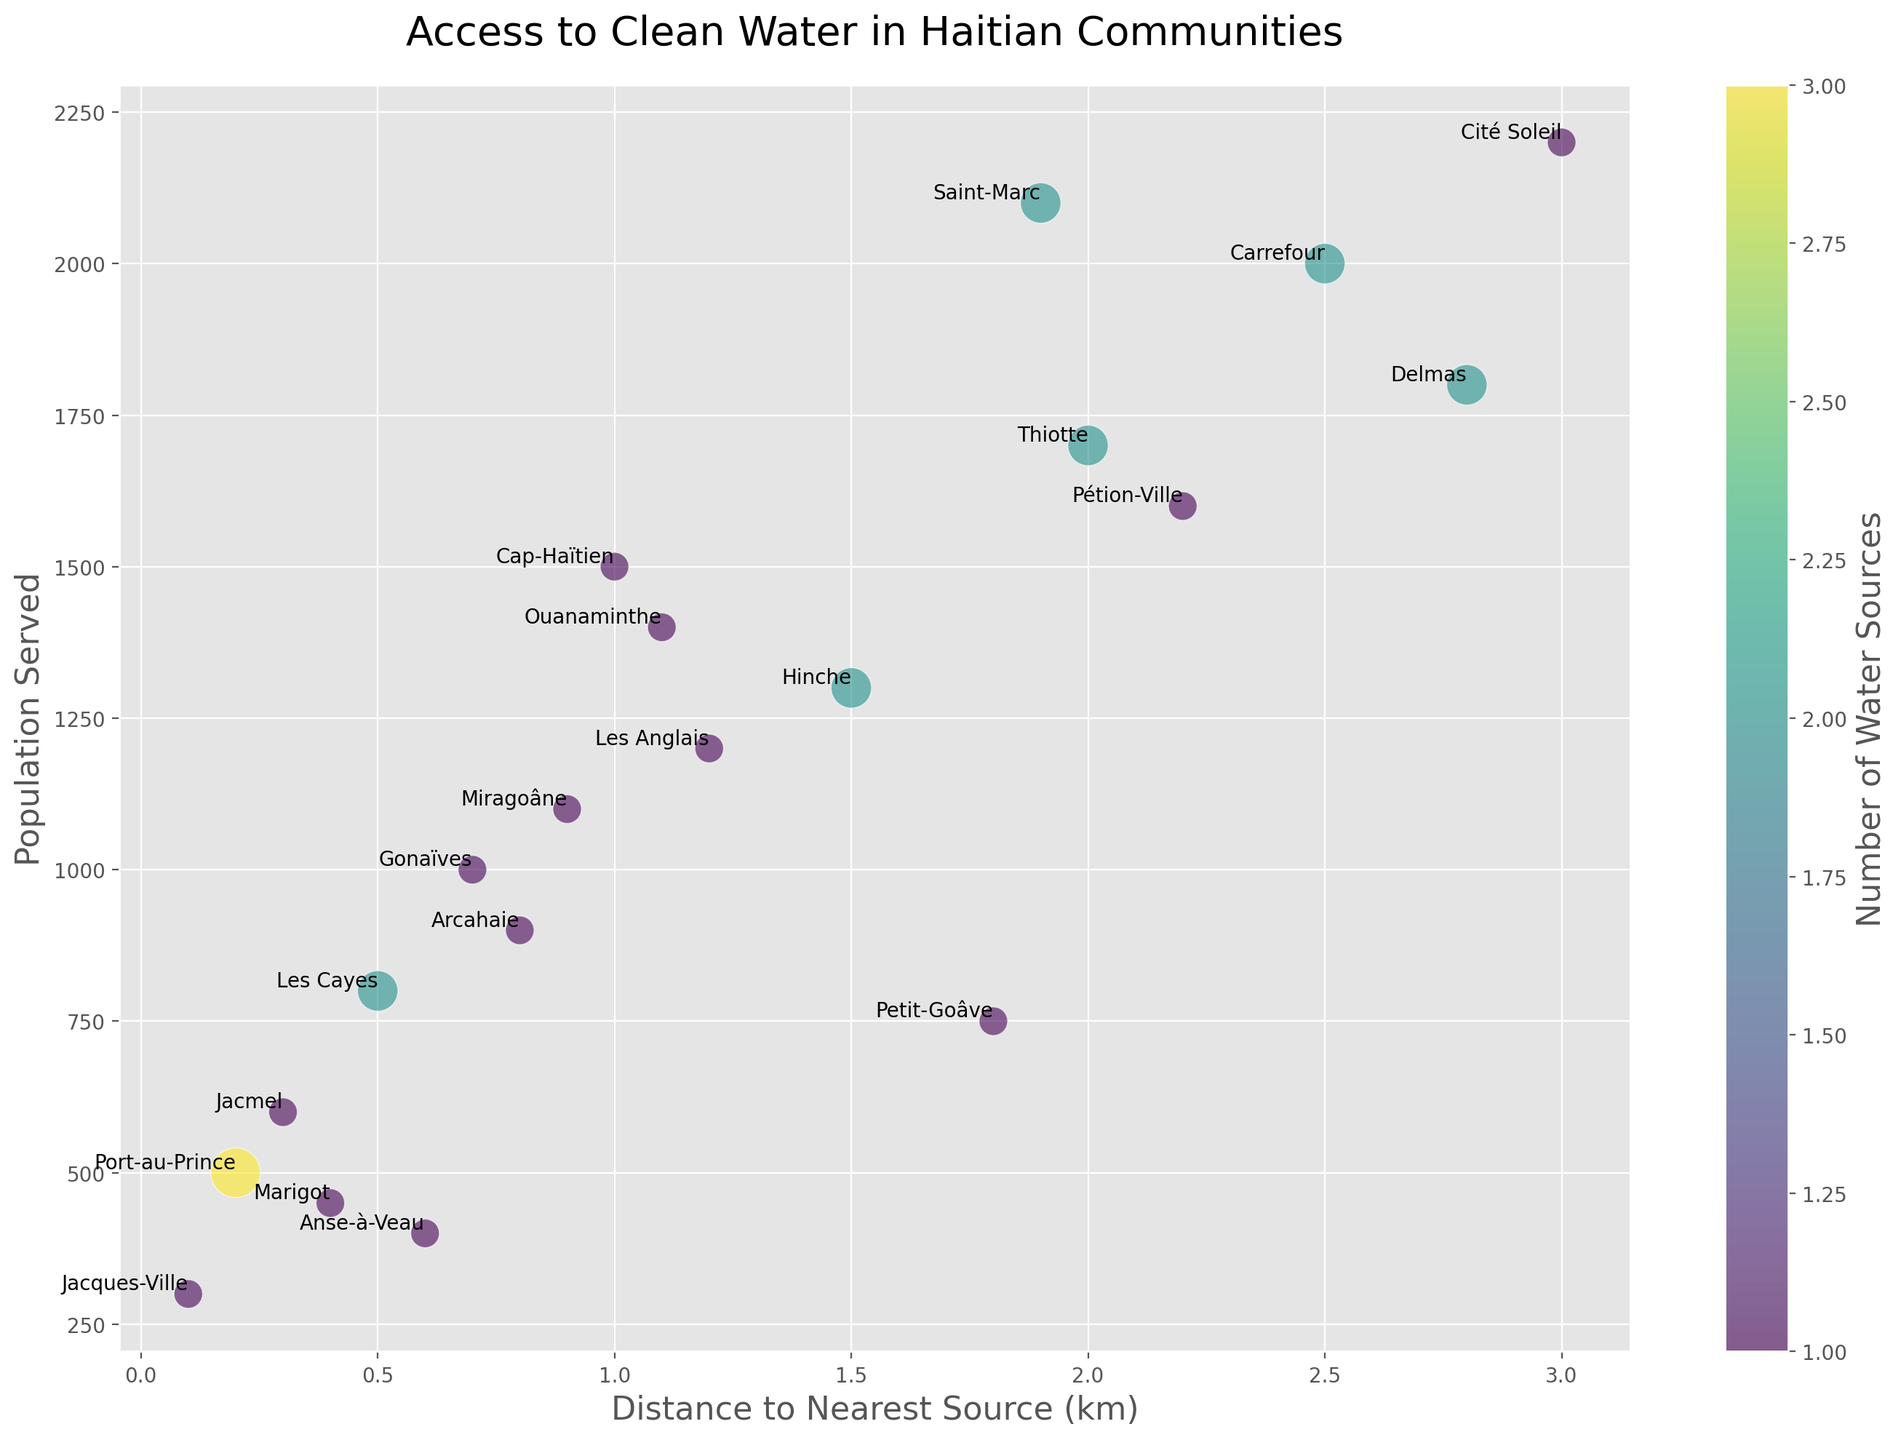What is the community with the shortest distance to the nearest water source? To find the community with the shortest distance, look for the smallest distance value on the x-axis. The community name next to the smallest distance value of 0.1 km is Jacques-Ville.
Answer: Jacques-Ville Which community serves the highest population? Look at the y-axis to find the highest value representing population served. The label next to the highest population value of 2200 people is Cité Soleil.
Answer: Cité Soleil What is the average distance to the nearest water source for communities with more than one water source? Identify communities with more than one water source (3, 2, 1, 2, 2, 2) and sum their corresponding distances (0.2 + 0.5 + 2.5 + 2.0 + 1.5 + 1.9). Divide the total distance by the number of communities (6). The average is (0.2 + 0.5 + 2.5 + 2.0 + 1.5 + 1.9)/6 = 8.6/6.
Answer: 1.43 km Does Petit-Goâve have a longer distance to the nearest water source compared to Léogâne? Identify the distance to the nearest water source for Petit-Goâve and Léogâne. Petit-Goâve has a distance of 1.8 km. Léogâne is not on the list, so comparison isn't possible based on the figure.
Answer: Unknown Which communities have the same number of water sources but different distances to the nearest source? Look for communities with an equal number of water sources but different distances. Carrefour and Delmas each have 2 sources with distances of 2.5 km and 2.8 km, respectively.
Answer: Carrefour, Delmas What's the total number of communities served with only one water source? Identify and count all communities with the number of water sources as 1 (Cap-Haïtien, Gonaïves, Jacmel, Petit-Goâve, Jacques-Ville, Miragoâne, Marigot, Cité Soleil, Les Anglais, Ouanaminthe, Arcahaie, Pétion-Ville, Anse-à-Veau). There are 13 communities.
Answer: 13 communities Which community has the largest bubble in the chart and how many water sources does it have? The largest bubble represents the highest number of water sources. The largest bubble size is for Port-au-Prince, which has 3 water sources.
Answer: Port-au-Prince, 3 Is there any community with a population served greater than 1500 but with only one water source? Look for communities with a population greater than 1500 on the y-axis and then check if their number of water sources is 1. Cité Soleil, Ouanaminthe, Pétion-Ville, and Cap-Haïtien fit the criteria.
Answer: Cité Soleil, Ouanaminthe, Pétion-Ville, Cap-Haïtien Which communities are more than 2 km away from the nearest water source? Identify and list communities with distances greater than 2 km (Carrefour: 2.5 km, Thiotte: 2.0 km, Delmas: 2.8 km, Pétion-Ville: 2.2 km).
Answer: Carrefour, Thiotte, Delmas, Pétion-Ville 